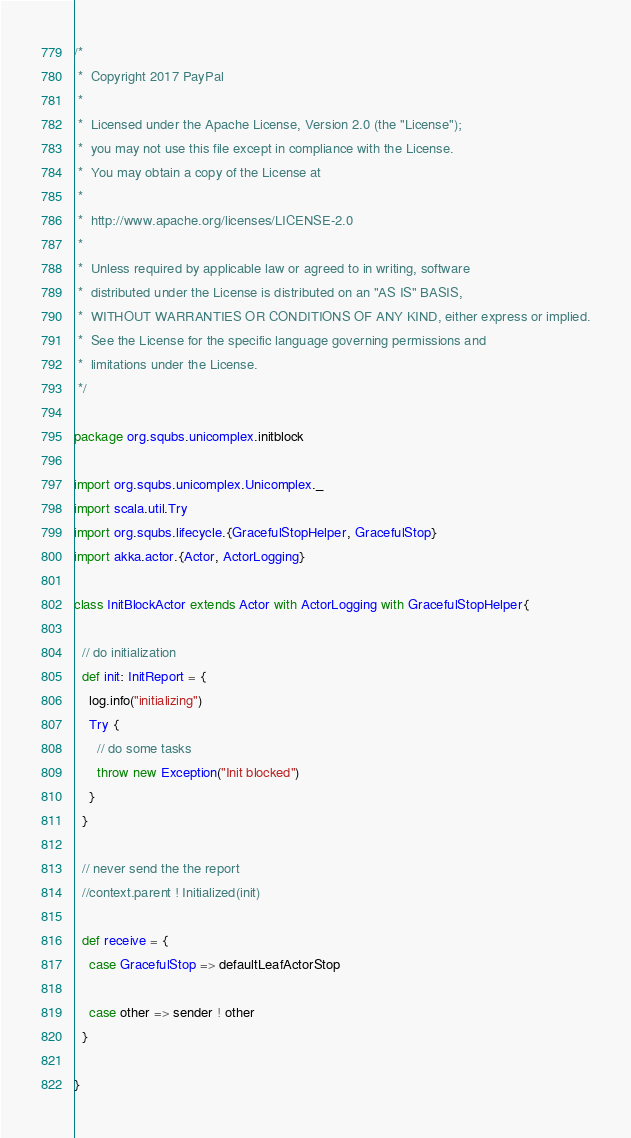<code> <loc_0><loc_0><loc_500><loc_500><_Scala_>/*
 *  Copyright 2017 PayPal
 *
 *  Licensed under the Apache License, Version 2.0 (the "License");
 *  you may not use this file except in compliance with the License.
 *  You may obtain a copy of the License at
 *
 *  http://www.apache.org/licenses/LICENSE-2.0
 *
 *  Unless required by applicable law or agreed to in writing, software
 *  distributed under the License is distributed on an "AS IS" BASIS,
 *  WITHOUT WARRANTIES OR CONDITIONS OF ANY KIND, either express or implied.
 *  See the License for the specific language governing permissions and
 *  limitations under the License.
 */

package org.squbs.unicomplex.initblock

import org.squbs.unicomplex.Unicomplex._
import scala.util.Try
import org.squbs.lifecycle.{GracefulStopHelper, GracefulStop}
import akka.actor.{Actor, ActorLogging}

class InitBlockActor extends Actor with ActorLogging with GracefulStopHelper{

  // do initialization
  def init: InitReport = {
    log.info("initializing")
    Try {
      // do some tasks
      throw new Exception("Init blocked")
    }
  }

  // never send the the report
  //context.parent ! Initialized(init)

  def receive = {
    case GracefulStop => defaultLeafActorStop

    case other => sender ! other
  }

}
</code> 